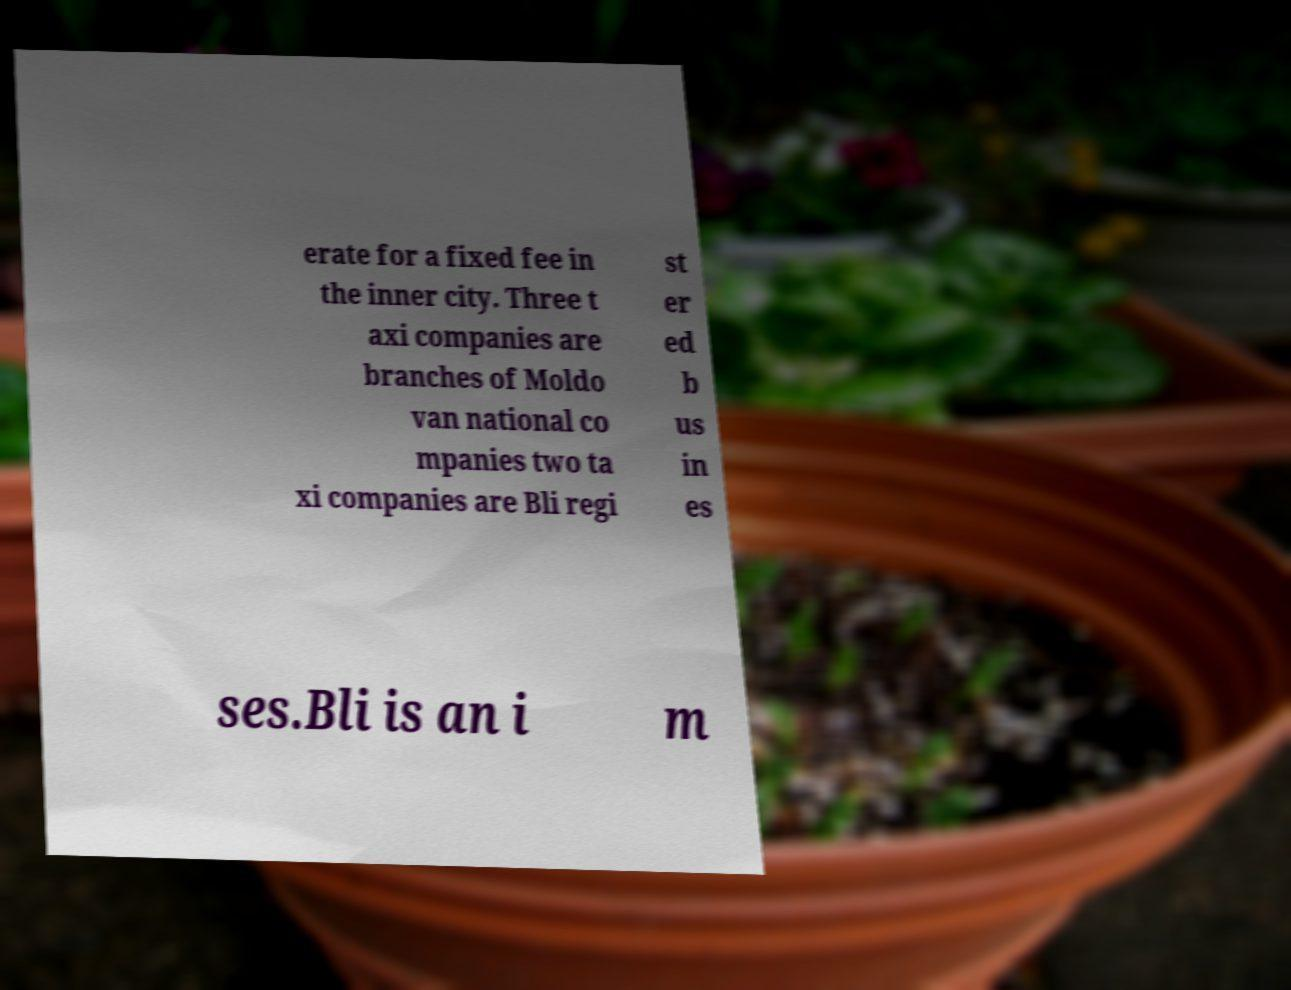I need the written content from this picture converted into text. Can you do that? erate for a fixed fee in the inner city. Three t axi companies are branches of Moldo van national co mpanies two ta xi companies are Bli regi st er ed b us in es ses.Bli is an i m 